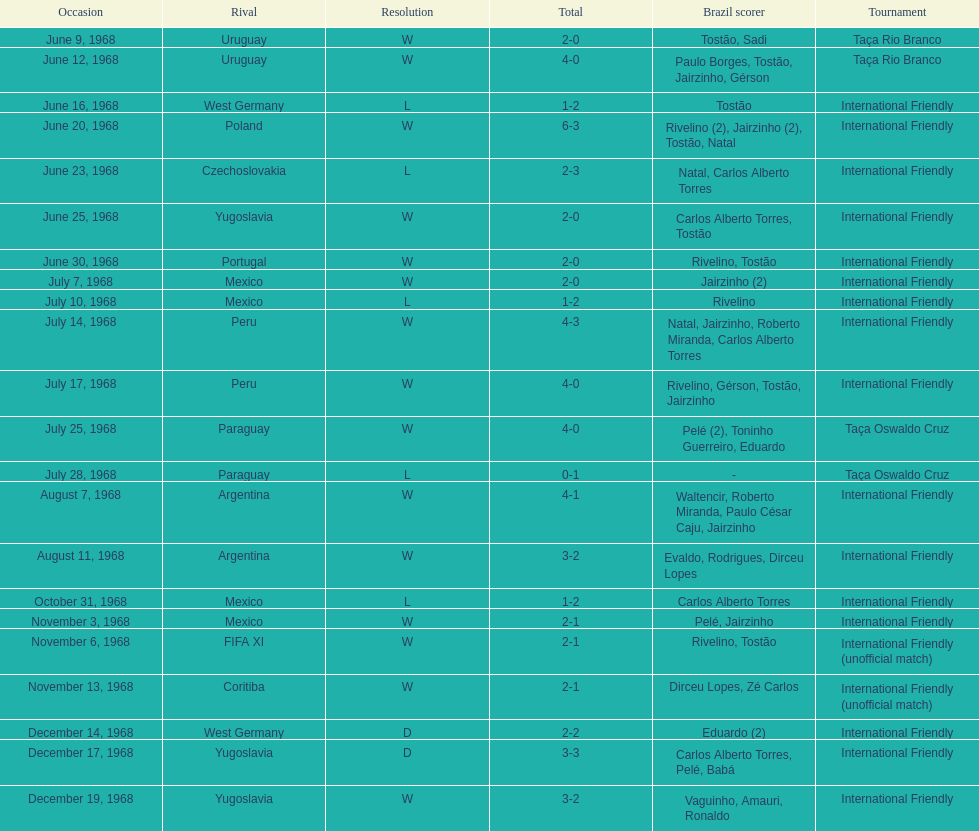What is the number of countries they have played? 11. 